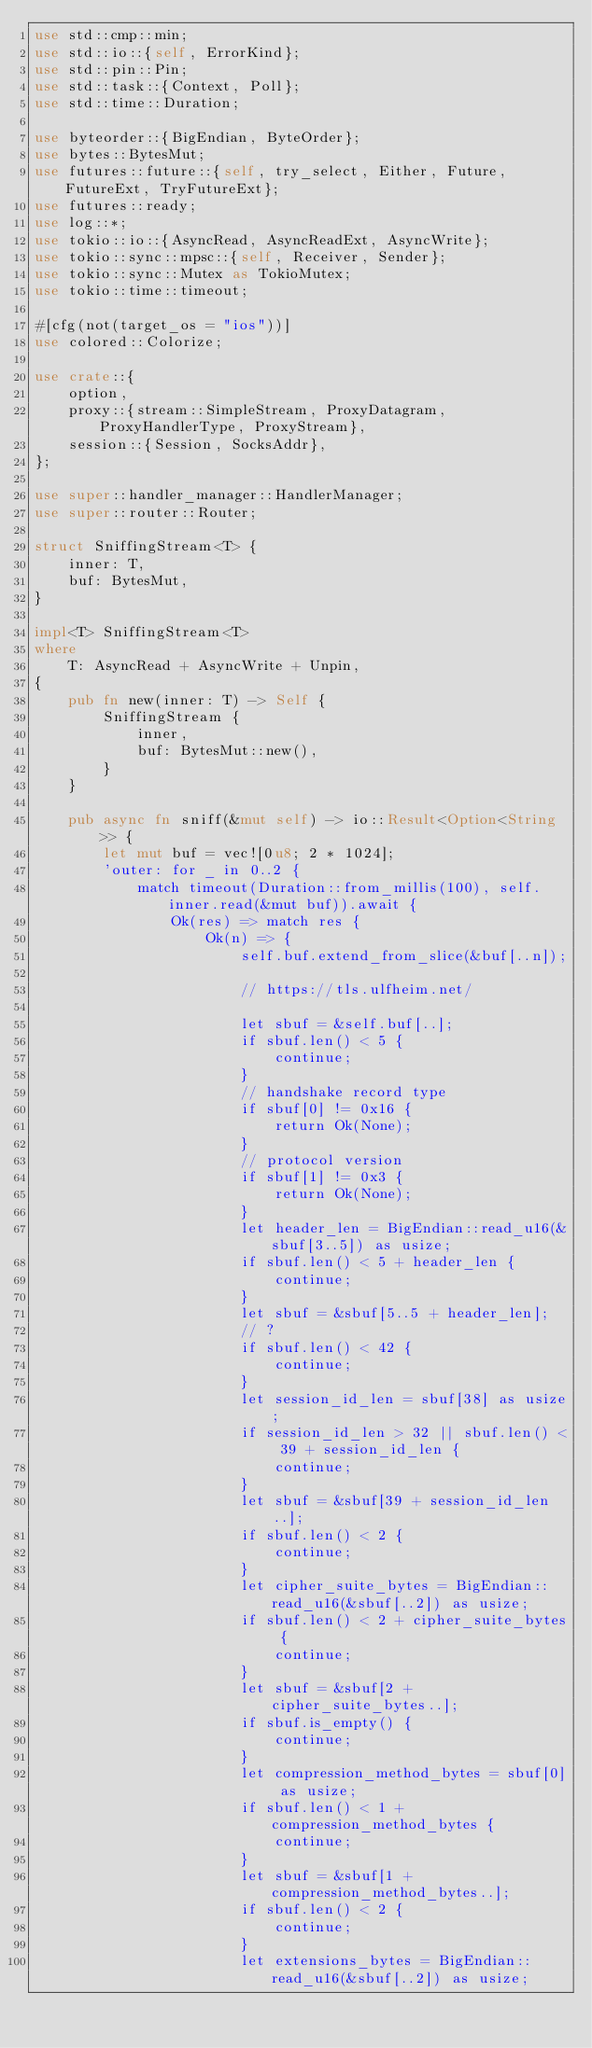<code> <loc_0><loc_0><loc_500><loc_500><_Rust_>use std::cmp::min;
use std::io::{self, ErrorKind};
use std::pin::Pin;
use std::task::{Context, Poll};
use std::time::Duration;

use byteorder::{BigEndian, ByteOrder};
use bytes::BytesMut;
use futures::future::{self, try_select, Either, Future, FutureExt, TryFutureExt};
use futures::ready;
use log::*;
use tokio::io::{AsyncRead, AsyncReadExt, AsyncWrite};
use tokio::sync::mpsc::{self, Receiver, Sender};
use tokio::sync::Mutex as TokioMutex;
use tokio::time::timeout;

#[cfg(not(target_os = "ios"))]
use colored::Colorize;

use crate::{
    option,
    proxy::{stream::SimpleStream, ProxyDatagram, ProxyHandlerType, ProxyStream},
    session::{Session, SocksAddr},
};

use super::handler_manager::HandlerManager;
use super::router::Router;

struct SniffingStream<T> {
    inner: T,
    buf: BytesMut,
}

impl<T> SniffingStream<T>
where
    T: AsyncRead + AsyncWrite + Unpin,
{
    pub fn new(inner: T) -> Self {
        SniffingStream {
            inner,
            buf: BytesMut::new(),
        }
    }

    pub async fn sniff(&mut self) -> io::Result<Option<String>> {
        let mut buf = vec![0u8; 2 * 1024];
        'outer: for _ in 0..2 {
            match timeout(Duration::from_millis(100), self.inner.read(&mut buf)).await {
                Ok(res) => match res {
                    Ok(n) => {
                        self.buf.extend_from_slice(&buf[..n]);

                        // https://tls.ulfheim.net/

                        let sbuf = &self.buf[..];
                        if sbuf.len() < 5 {
                            continue;
                        }
                        // handshake record type
                        if sbuf[0] != 0x16 {
                            return Ok(None);
                        }
                        // protocol version
                        if sbuf[1] != 0x3 {
                            return Ok(None);
                        }
                        let header_len = BigEndian::read_u16(&sbuf[3..5]) as usize;
                        if sbuf.len() < 5 + header_len {
                            continue;
                        }
                        let sbuf = &sbuf[5..5 + header_len];
                        // ?
                        if sbuf.len() < 42 {
                            continue;
                        }
                        let session_id_len = sbuf[38] as usize;
                        if session_id_len > 32 || sbuf.len() < 39 + session_id_len {
                            continue;
                        }
                        let sbuf = &sbuf[39 + session_id_len..];
                        if sbuf.len() < 2 {
                            continue;
                        }
                        let cipher_suite_bytes = BigEndian::read_u16(&sbuf[..2]) as usize;
                        if sbuf.len() < 2 + cipher_suite_bytes {
                            continue;
                        }
                        let sbuf = &sbuf[2 + cipher_suite_bytes..];
                        if sbuf.is_empty() {
                            continue;
                        }
                        let compression_method_bytes = sbuf[0] as usize;
                        if sbuf.len() < 1 + compression_method_bytes {
                            continue;
                        }
                        let sbuf = &sbuf[1 + compression_method_bytes..];
                        if sbuf.len() < 2 {
                            continue;
                        }
                        let extensions_bytes = BigEndian::read_u16(&sbuf[..2]) as usize;</code> 